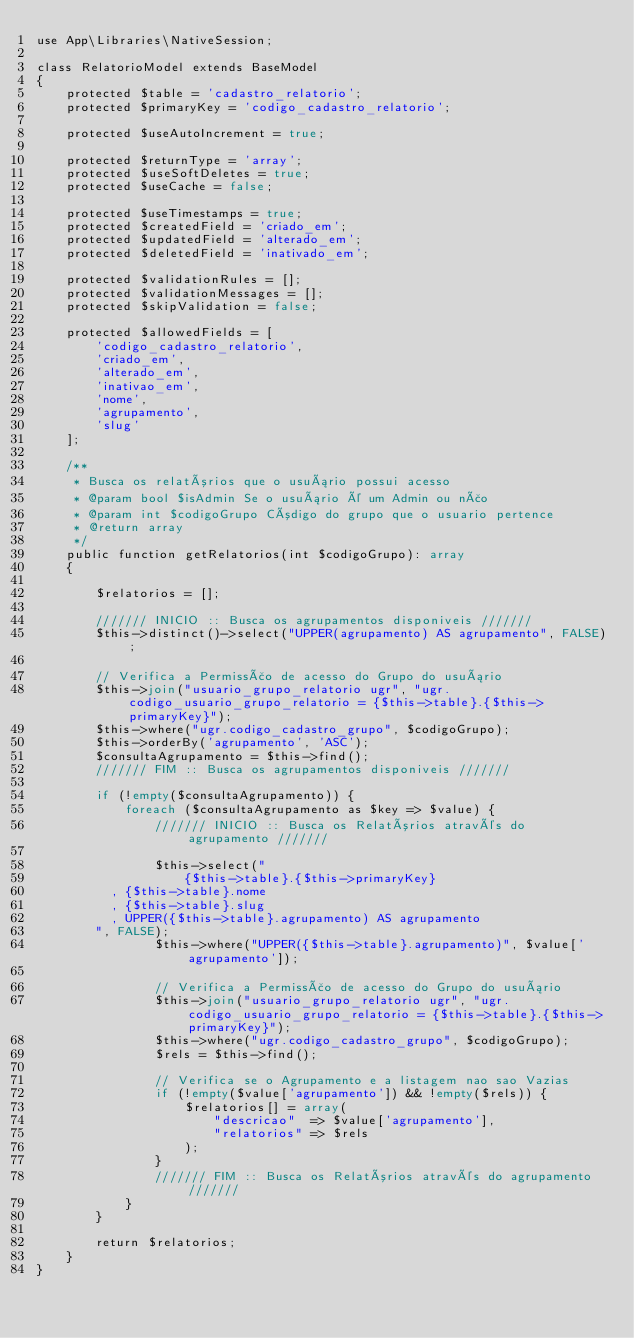Convert code to text. <code><loc_0><loc_0><loc_500><loc_500><_PHP_>use App\Libraries\NativeSession;

class RelatorioModel extends BaseModel
{
    protected $table = 'cadastro_relatorio';
    protected $primaryKey = 'codigo_cadastro_relatorio';

    protected $useAutoIncrement = true;

    protected $returnType = 'array';
    protected $useSoftDeletes = true;
    protected $useCache = false;

    protected $useTimestamps = true;
    protected $createdField = 'criado_em';
    protected $updatedField = 'alterado_em';
    protected $deletedField = 'inativado_em';

    protected $validationRules = [];
    protected $validationMessages = [];
    protected $skipValidation = false;

    protected $allowedFields = [
        'codigo_cadastro_relatorio',
        'criado_em',
        'alterado_em',
        'inativao_em',
        'nome',
        'agrupamento',
        'slug'
    ];

    /**
     * Busca os relatórios que o usuário possui acesso
     * @param bool $isAdmin Se o usuário é um Admin ou não
     * @param int $codigoGrupo Código do grupo que o usuario pertence
     * @return array
     */
    public function getRelatorios(int $codigoGrupo): array
    {

        $relatorios = [];

        /////// INICIO :: Busca os agrupamentos disponiveis ///////
        $this->distinct()->select("UPPER(agrupamento) AS agrupamento", FALSE);

        // Verifica a Permissão de acesso do Grupo do usuário
        $this->join("usuario_grupo_relatorio ugr", "ugr.codigo_usuario_grupo_relatorio = {$this->table}.{$this->primaryKey}");
        $this->where("ugr.codigo_cadastro_grupo", $codigoGrupo);
        $this->orderBy('agrupamento', 'ASC');
        $consultaAgrupamento = $this->find();
        /////// FIM :: Busca os agrupamentos disponiveis ///////

        if (!empty($consultaAgrupamento)) {
            foreach ($consultaAgrupamento as $key => $value) {
                /////// INICIO :: Busca os Relatórios através do agrupamento ///////

                $this->select("
                    {$this->table}.{$this->primaryKey}
				  , {$this->table}.nome
				  , {$this->table}.slug
				  , UPPER({$this->table}.agrupamento) AS agrupamento
				", FALSE);
                $this->where("UPPER({$this->table}.agrupamento)", $value['agrupamento']);

                // Verifica a Permissão de acesso do Grupo do usuário
                $this->join("usuario_grupo_relatorio ugr", "ugr.codigo_usuario_grupo_relatorio = {$this->table}.{$this->primaryKey}");
                $this->where("ugr.codigo_cadastro_grupo", $codigoGrupo);
                $rels = $this->find();

                // Verifica se o Agrupamento e a listagem nao sao Vazias
                if (!empty($value['agrupamento']) && !empty($rels)) {
                    $relatorios[] = array(
                        "descricao"  => $value['agrupamento'],
                        "relatorios" => $rels
                    );
                }
                /////// FIM :: Busca os Relatórios através do agrupamento ///////
            }
        }

        return $relatorios;
    }
}
</code> 